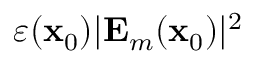Convert formula to latex. <formula><loc_0><loc_0><loc_500><loc_500>\varepsilon ( x _ { 0 } ) | E _ { m } ( x _ { 0 } ) | ^ { 2 }</formula> 